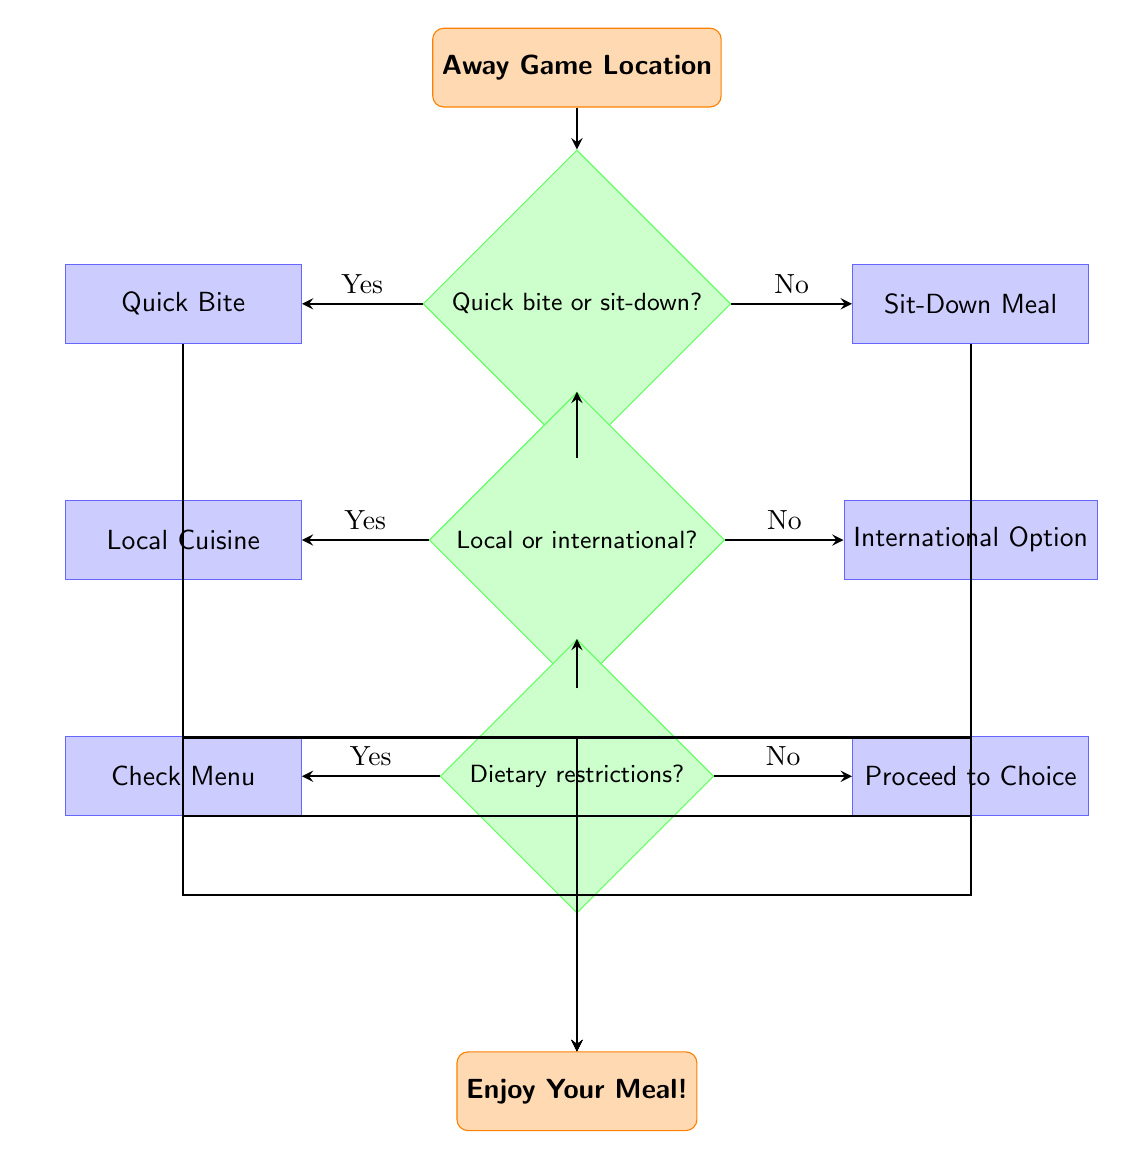What is the starting point of the flow chart? The starting point of the flow chart is labeled "Away Game Location", which indicates where the decision-making process begins.
Answer: Away Game Location How many decision points are present in the diagram? The diagram contains three decision points, as indicated by the diamond-shaped nodes that ask questions about meal preferences and dietary restrictions.
Answer: 3 What are the options for a quick bite? The flow chart lists three options under the "Quick Bite" node: "Joe's Pizza", "Subway", and "Taco Bell", which are presented as choices for a quick meal.
Answer: Joe's Pizza, Subway, Taco Bell If I select "Sit-Down Meal", what choices do I have? Under the "Sit-Down Meal" node, the options provided are "Olive Garden", "Texas Roadhouse", and "Cheesecake Factory", which are the choices available for a sit-down meal.
Answer: Olive Garden, Texas Roadhouse, Cheesecake Factory What happens if I choose "Local Cuisine" and have dietary restrictions? If "Local Cuisine" is chosen and there are dietary restrictions, the flow chart indicates to "Check Menu for Options", suggesting that the next step is to verify compatible menu items.
Answer: Check Menu for Options What are the last actions taken in the flow chart? The final actions leading to the end node instruct to "Enjoy Your Meal!" after following the choices depending on previous decisions, concluding the decision-making process.
Answer: Enjoy Your Meal! 